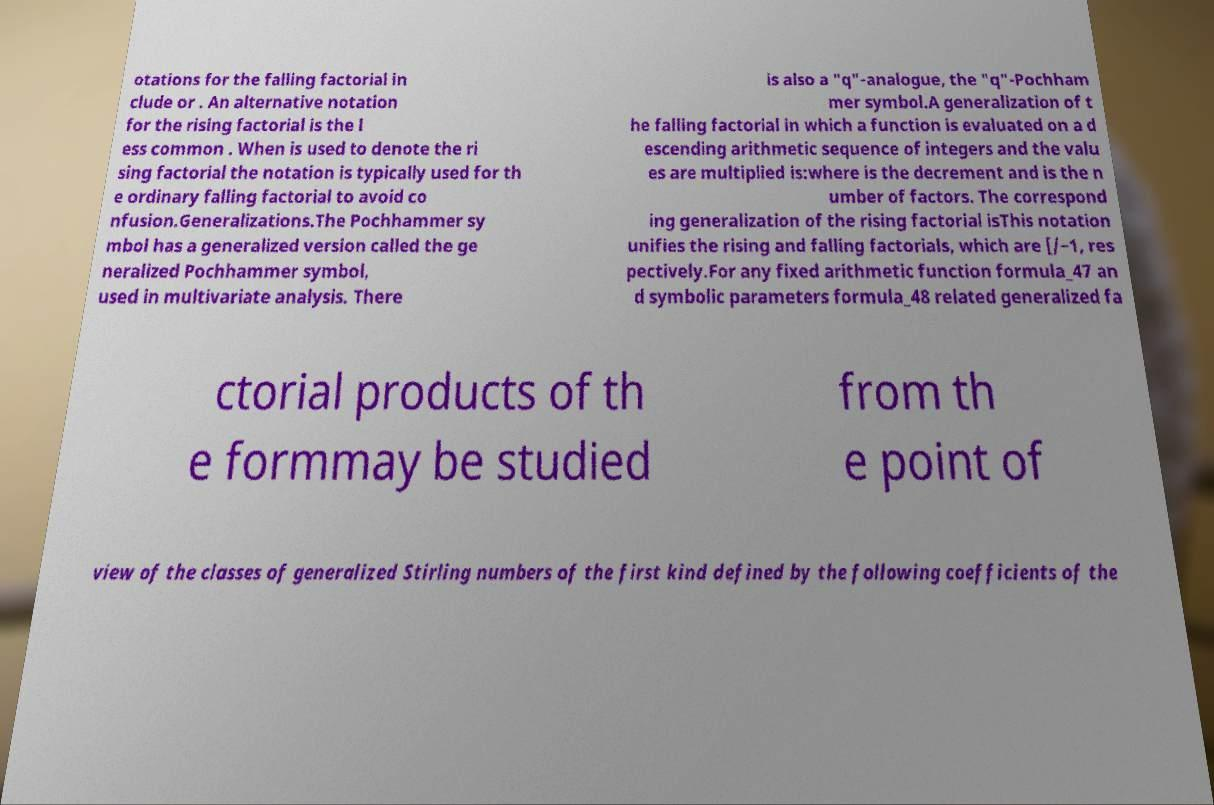For documentation purposes, I need the text within this image transcribed. Could you provide that? otations for the falling factorial in clude or . An alternative notation for the rising factorial is the l ess common . When is used to denote the ri sing factorial the notation is typically used for th e ordinary falling factorial to avoid co nfusion.Generalizations.The Pochhammer sy mbol has a generalized version called the ge neralized Pochhammer symbol, used in multivariate analysis. There is also a "q"-analogue, the "q"-Pochham mer symbol.A generalization of t he falling factorial in which a function is evaluated on a d escending arithmetic sequence of integers and the valu es are multiplied is:where is the decrement and is the n umber of factors. The correspond ing generalization of the rising factorial isThis notation unifies the rising and falling factorials, which are [/−1, res pectively.For any fixed arithmetic function formula_47 an d symbolic parameters formula_48 related generalized fa ctorial products of th e formmay be studied from th e point of view of the classes of generalized Stirling numbers of the first kind defined by the following coefficients of the 